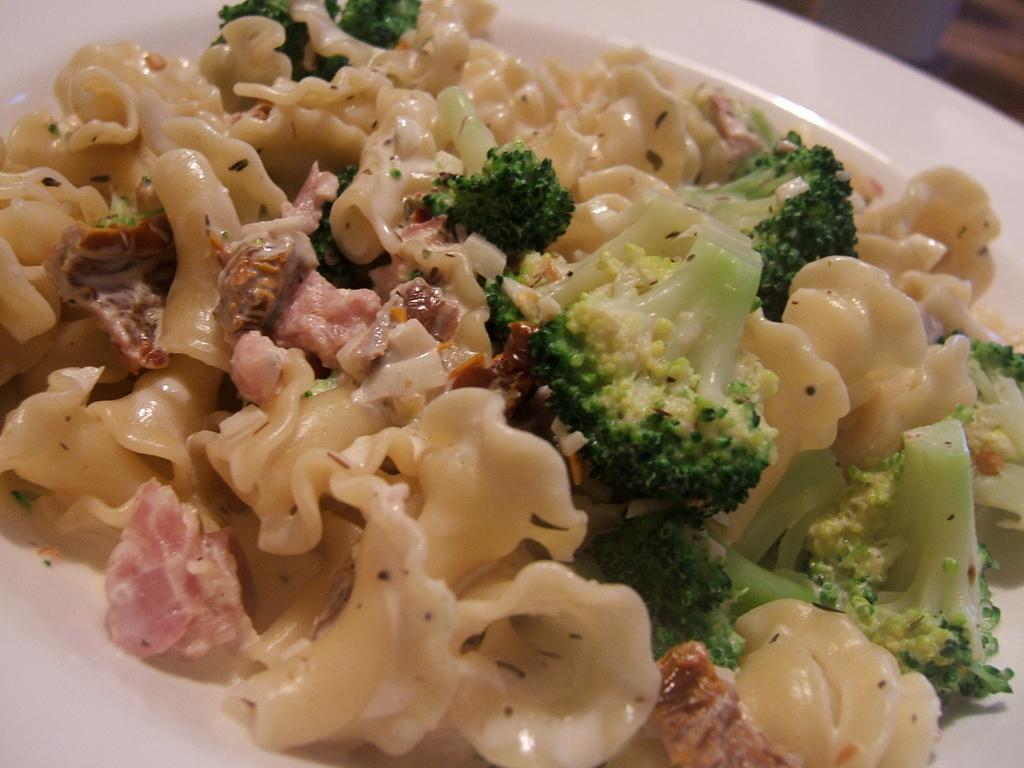Can you describe this image briefly? In this picture we can see broccoli and food on the plate. 